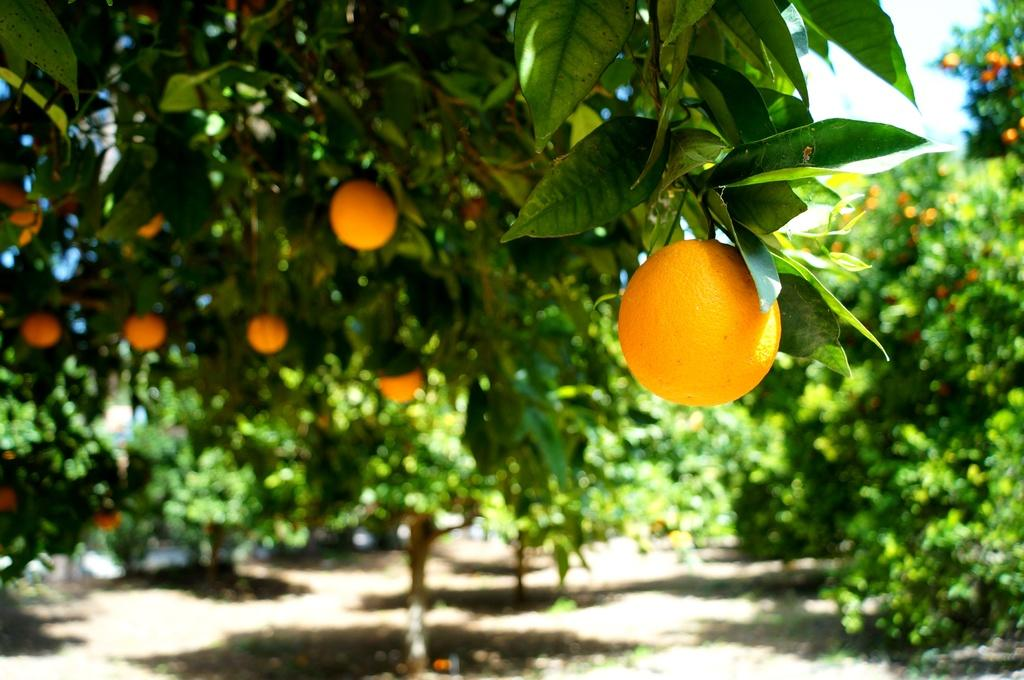What type of trees are present in the image? There are orange trees in the image. What color is the sky in the image? The sky is white in the image. How would you describe the background of the image? The background is blurred in the image. What is the size of the stitch used to create the blurred background in the image? There is no stitch present in the image, as the blurred background is a result of the camera's focus and not a physical stitch. 